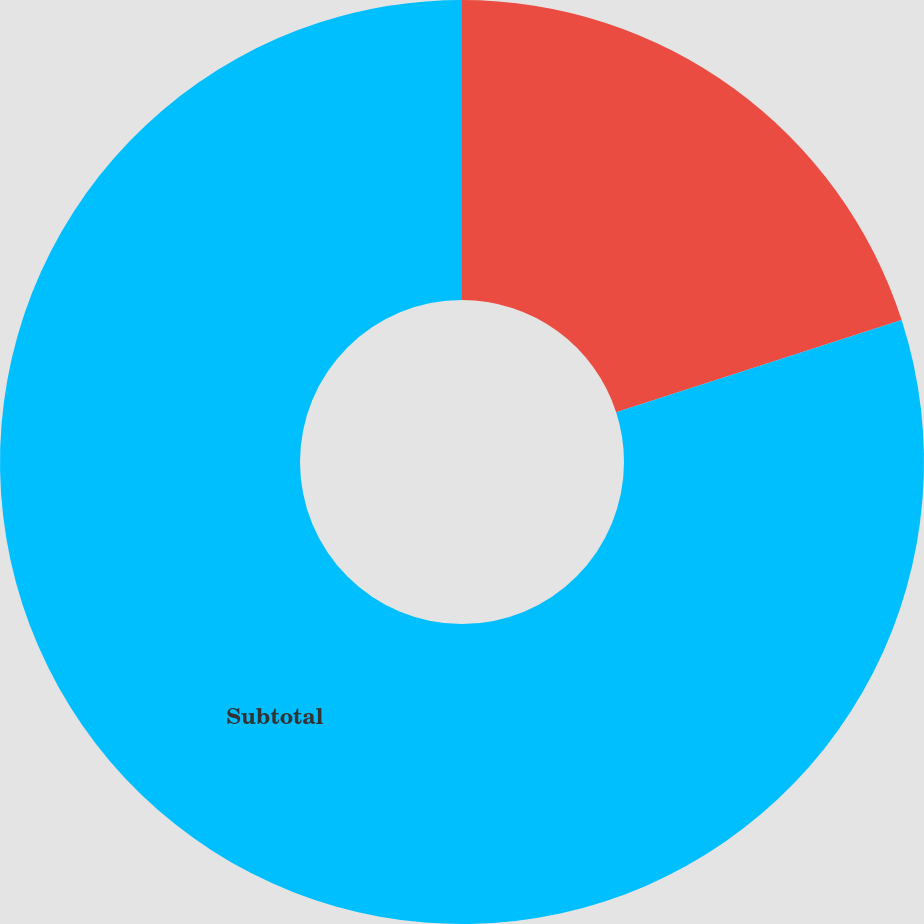<chart> <loc_0><loc_0><loc_500><loc_500><pie_chart><ecel><fcel>Subtotal<nl><fcel>20.03%<fcel>79.97%<nl></chart> 